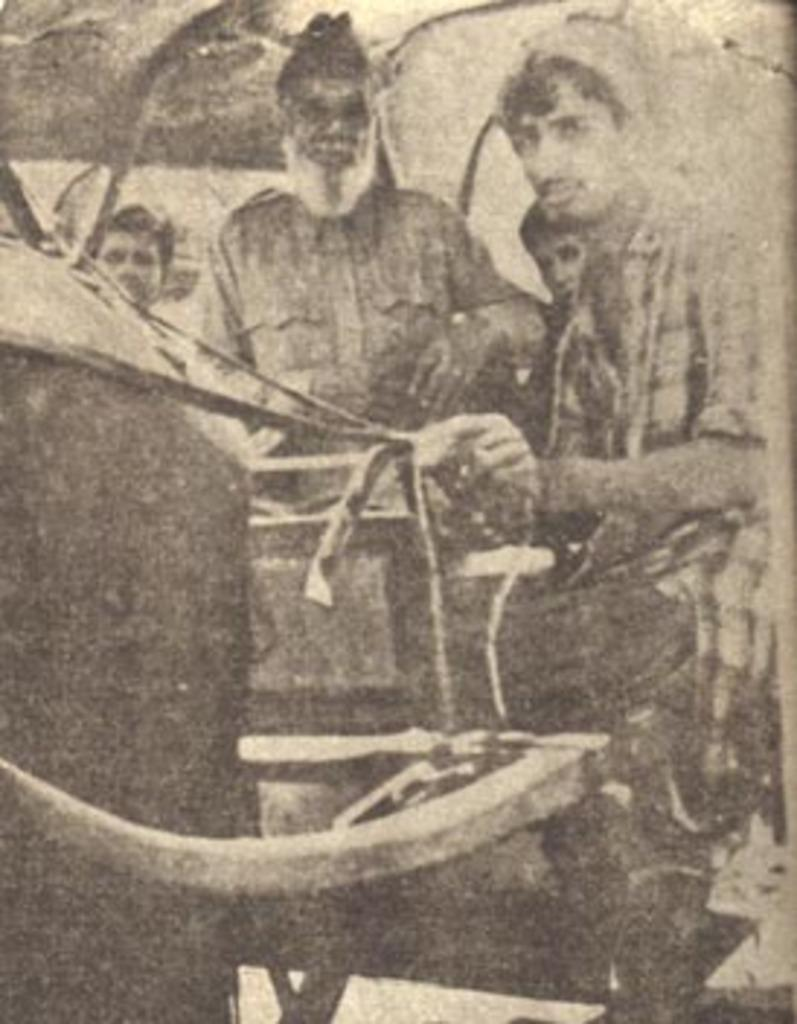What is the color scheme of the picture? The picture is black and white. What can be seen in the picture besides the color scheme? There are people and objects in the picture. What type of mine is visible in the picture? There is no mine present in the picture; it is a black and white image featuring people and objects. Can you tell me how many men are in the picture? The provided facts do not specify the number of people in the picture, nor do they mention any men specifically. 